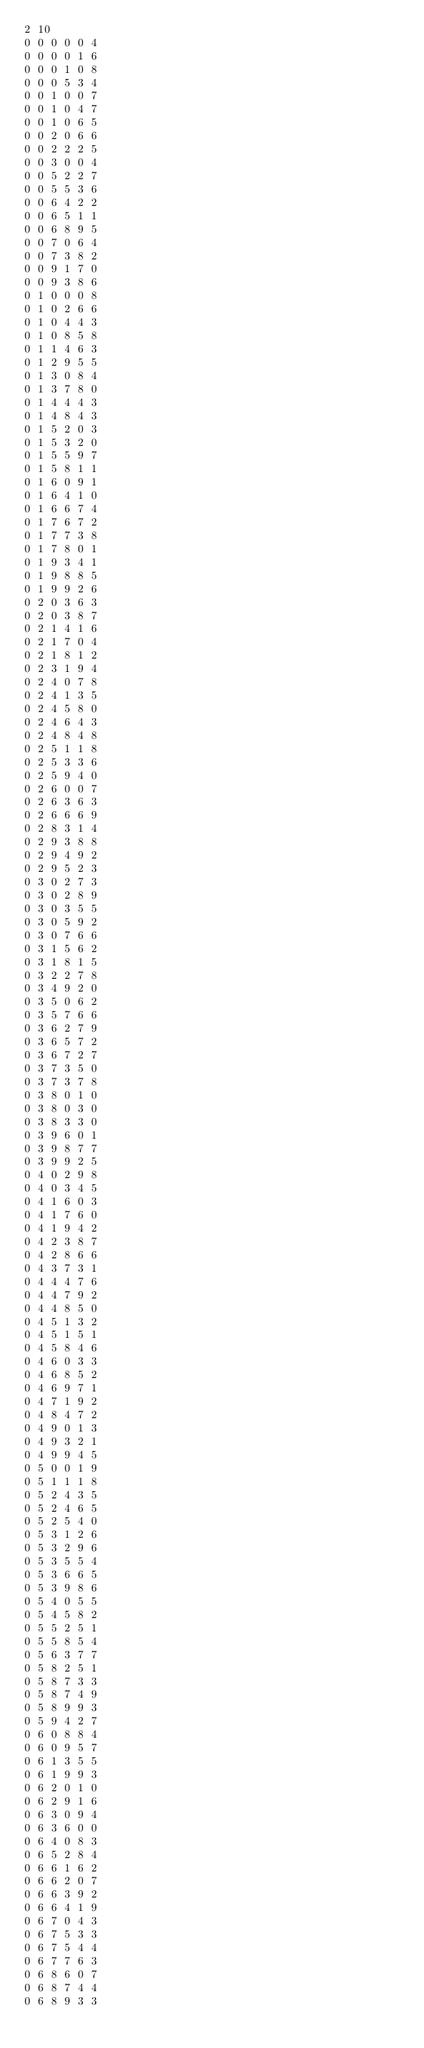<code> <loc_0><loc_0><loc_500><loc_500><_SQL_>2 10
0 0 0 0 0 4
0 0 0 0 1 6
0 0 0 1 0 8
0 0 0 5 3 4
0 0 1 0 0 7
0 0 1 0 4 7
0 0 1 0 6 5
0 0 2 0 6 6
0 0 2 2 2 5
0 0 3 0 0 4
0 0 5 2 2 7
0 0 5 5 3 6
0 0 6 4 2 2
0 0 6 5 1 1
0 0 6 8 9 5
0 0 7 0 6 4
0 0 7 3 8 2
0 0 9 1 7 0
0 0 9 3 8 6
0 1 0 0 0 8
0 1 0 2 6 6
0 1 0 4 4 3
0 1 0 8 5 8
0 1 1 4 6 3
0 1 2 9 5 5
0 1 3 0 8 4
0 1 3 7 8 0
0 1 4 4 4 3
0 1 4 8 4 3
0 1 5 2 0 3
0 1 5 3 2 0
0 1 5 5 9 7
0 1 5 8 1 1
0 1 6 0 9 1
0 1 6 4 1 0
0 1 6 6 7 4
0 1 7 6 7 2
0 1 7 7 3 8
0 1 7 8 0 1
0 1 9 3 4 1
0 1 9 8 8 5
0 1 9 9 2 6
0 2 0 3 6 3
0 2 0 3 8 7
0 2 1 4 1 6
0 2 1 7 0 4
0 2 1 8 1 2
0 2 3 1 9 4
0 2 4 0 7 8
0 2 4 1 3 5
0 2 4 5 8 0
0 2 4 6 4 3
0 2 4 8 4 8
0 2 5 1 1 8
0 2 5 3 3 6
0 2 5 9 4 0
0 2 6 0 0 7
0 2 6 3 6 3
0 2 6 6 6 9
0 2 8 3 1 4
0 2 9 3 8 8
0 2 9 4 9 2
0 2 9 5 2 3
0 3 0 2 7 3
0 3 0 2 8 9
0 3 0 3 5 5
0 3 0 5 9 2
0 3 0 7 6 6
0 3 1 5 6 2
0 3 1 8 1 5
0 3 2 2 7 8
0 3 4 9 2 0
0 3 5 0 6 2
0 3 5 7 6 6
0 3 6 2 7 9
0 3 6 5 7 2
0 3 6 7 2 7
0 3 7 3 5 0
0 3 7 3 7 8
0 3 8 0 1 0
0 3 8 0 3 0
0 3 8 3 3 0
0 3 9 6 0 1
0 3 9 8 7 7
0 3 9 9 2 5
0 4 0 2 9 8
0 4 0 3 4 5
0 4 1 6 0 3
0 4 1 7 6 0
0 4 1 9 4 2
0 4 2 3 8 7
0 4 2 8 6 6
0 4 3 7 3 1
0 4 4 4 7 6
0 4 4 7 9 2
0 4 4 8 5 0
0 4 5 1 3 2
0 4 5 1 5 1
0 4 5 8 4 6
0 4 6 0 3 3
0 4 6 8 5 2
0 4 6 9 7 1
0 4 7 1 9 2
0 4 8 4 7 2
0 4 9 0 1 3
0 4 9 3 2 1
0 4 9 9 4 5
0 5 0 0 1 9
0 5 1 1 1 8
0 5 2 4 3 5
0 5 2 4 6 5
0 5 2 5 4 0
0 5 3 1 2 6
0 5 3 2 9 6
0 5 3 5 5 4
0 5 3 6 6 5
0 5 3 9 8 6
0 5 4 0 5 5
0 5 4 5 8 2
0 5 5 2 5 1
0 5 5 8 5 4
0 5 6 3 7 7
0 5 8 2 5 1
0 5 8 7 3 3
0 5 8 7 4 9
0 5 8 9 9 3
0 5 9 4 2 7
0 6 0 8 8 4
0 6 0 9 5 7
0 6 1 3 5 5
0 6 1 9 9 3
0 6 2 0 1 0
0 6 2 9 1 6
0 6 3 0 9 4
0 6 3 6 0 0
0 6 4 0 8 3
0 6 5 2 8 4
0 6 6 1 6 2
0 6 6 2 0 7
0 6 6 3 9 2
0 6 6 4 1 9
0 6 7 0 4 3
0 6 7 5 3 3
0 6 7 5 4 4
0 6 7 7 6 3
0 6 8 6 0 7
0 6 8 7 4 4
0 6 8 9 3 3</code> 